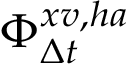Convert formula to latex. <formula><loc_0><loc_0><loc_500><loc_500>\Phi _ { \Delta t } ^ { x v , h a }</formula> 